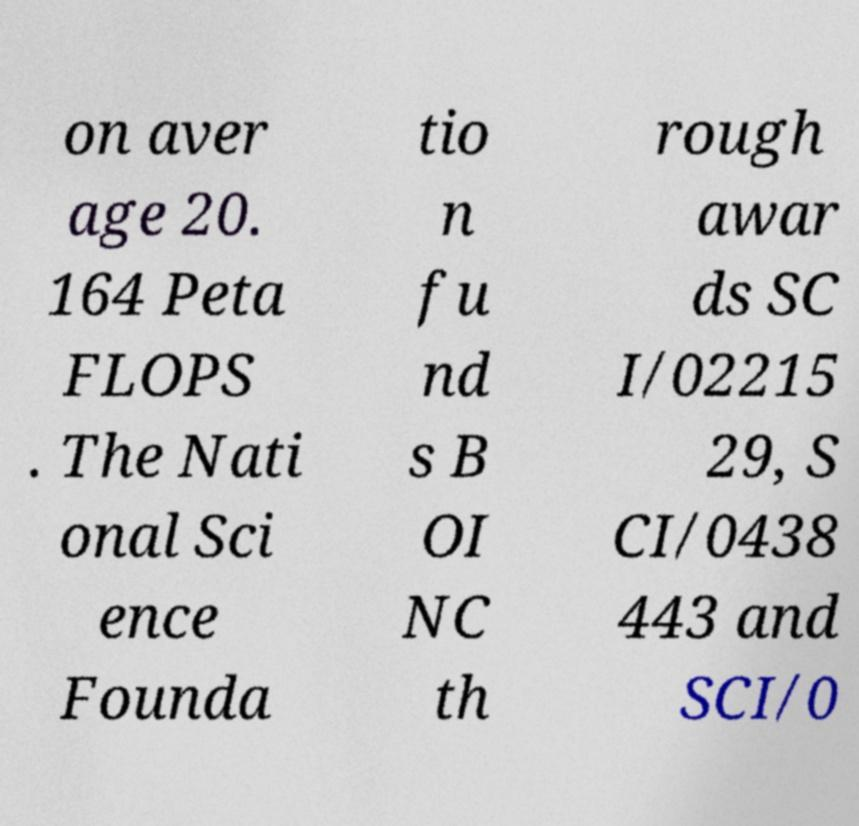What messages or text are displayed in this image? I need them in a readable, typed format. on aver age 20. 164 Peta FLOPS . The Nati onal Sci ence Founda tio n fu nd s B OI NC th rough awar ds SC I/02215 29, S CI/0438 443 and SCI/0 